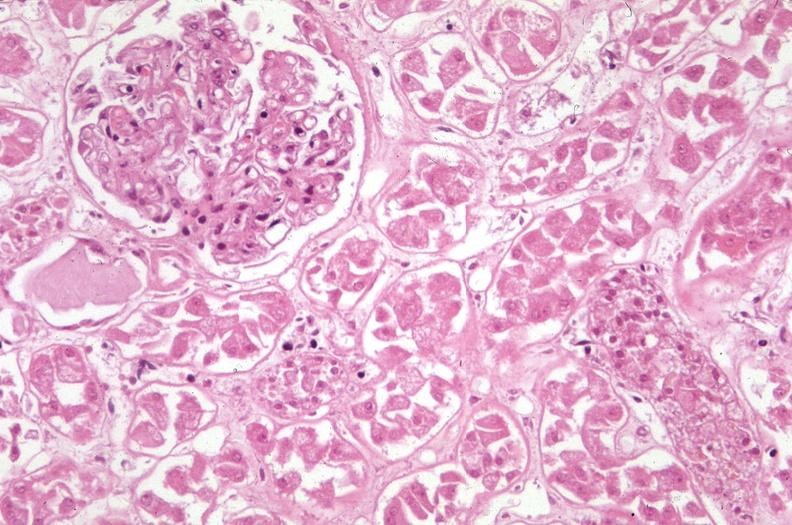what does this image show?
Answer the question using a single word or phrase. Kidney 